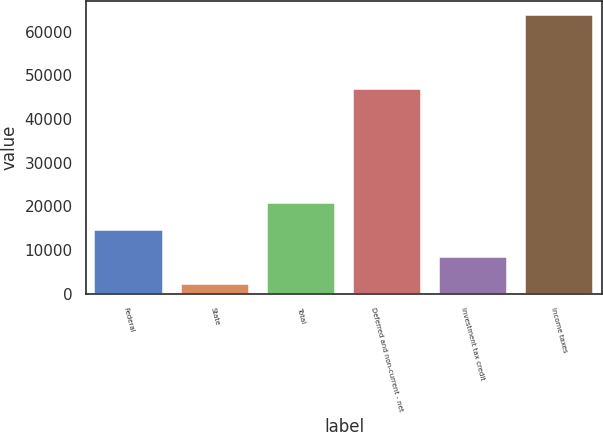Convert chart to OTSL. <chart><loc_0><loc_0><loc_500><loc_500><bar_chart><fcel>Federal<fcel>State<fcel>Total<fcel>Deferred and non-current - net<fcel>Investment tax credit<fcel>Income taxes<nl><fcel>14576.4<fcel>2257<fcel>20736.1<fcel>46984<fcel>8416.7<fcel>63854<nl></chart> 